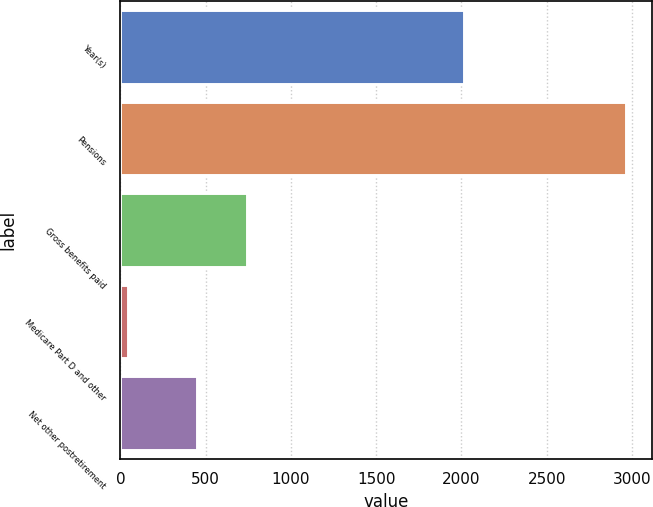Convert chart. <chart><loc_0><loc_0><loc_500><loc_500><bar_chart><fcel>Year(s)<fcel>Pensions<fcel>Gross benefits paid<fcel>Medicare Part D and other<fcel>Net other postretirement<nl><fcel>2013<fcel>2968<fcel>742.2<fcel>46<fcel>450<nl></chart> 